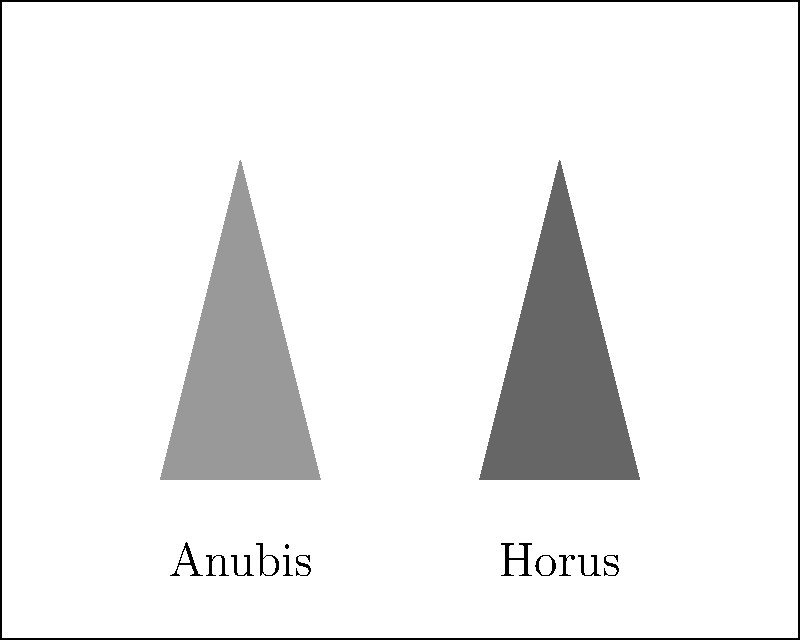In the ancient Egyptian temple fresco depicted above, what is the likely symbolic meaning of the juxtaposition of Anubis and Horus figures? To interpret the symbolic meaning of the juxtaposition of Anubis and Horus in this Egyptian temple fresco, we need to consider the following steps:

1. Identify the deities:
   - Anubis: God of mummification and the afterlife
   - Horus: God of kingship and the sky

2. Understand their roles:
   - Anubis guides souls through the underworld
   - Horus represents royal power and divine kingship

3. Analyze their juxtaposition:
   - Placing these gods side by side suggests a connection between their roles

4. Consider the context of a temple fresco:
   - Temple art often depicts religious and cosmological concepts

5. Interpret the symbolism:
   - The juxtaposition likely represents the transition from death to divine kingship
   - It symbolizes the journey of the deceased pharaoh from the underworld to his place among the gods

6. Conclude the meaning:
   - This arrangement symbolizes the cycle of death and rebirth in royal ideology
   - It reinforces the concept of the pharaoh's divine nature and eternal rule
Answer: Transition from death to divine kingship 